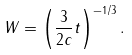<formula> <loc_0><loc_0><loc_500><loc_500>W = \left ( \frac { 3 } { 2 c } t \right ) ^ { - 1 / 3 } .</formula> 